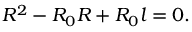Convert formula to latex. <formula><loc_0><loc_0><loc_500><loc_500>R ^ { 2 } - R _ { 0 } R + R _ { 0 } l = 0 .</formula> 